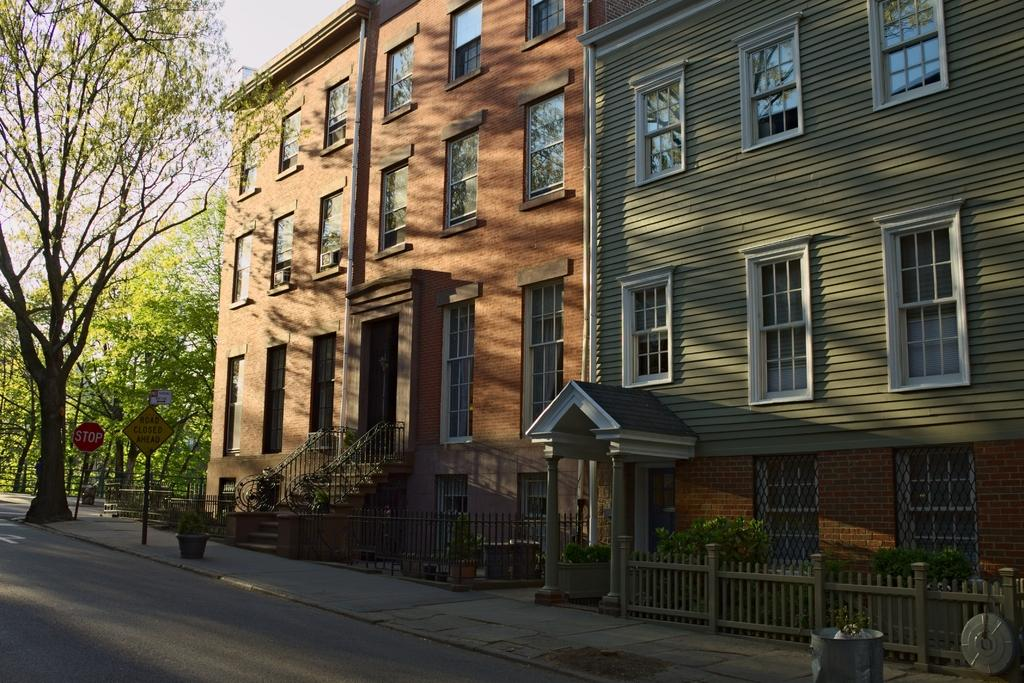How many buildings can be seen in the image? There are 2 buildings in the image. What is located on the left side of the image? There are trees on the left side of the image. What can be found on the footpath at the bottom of the image? There are sign boards on the boards on the footpath at the bottom of the image. What is visible in the image that people might use for transportation? There is a road visible in the image. What type of discovery was made in the territory depicted in the image? There is no mention of a discovery or territory in the image; it simply shows 2 buildings, trees, sign boards, and a road. 